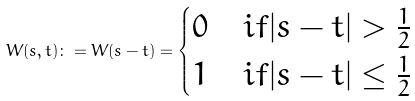Convert formula to latex. <formula><loc_0><loc_0><loc_500><loc_500>W ( s , t ) \colon = W ( s - t ) = \begin{cases} 0 & i f | s - t | > \frac { 1 } { 2 } \\ 1 & i f | s - t | \leq \frac { 1 } { 2 } \\ \end{cases}</formula> 